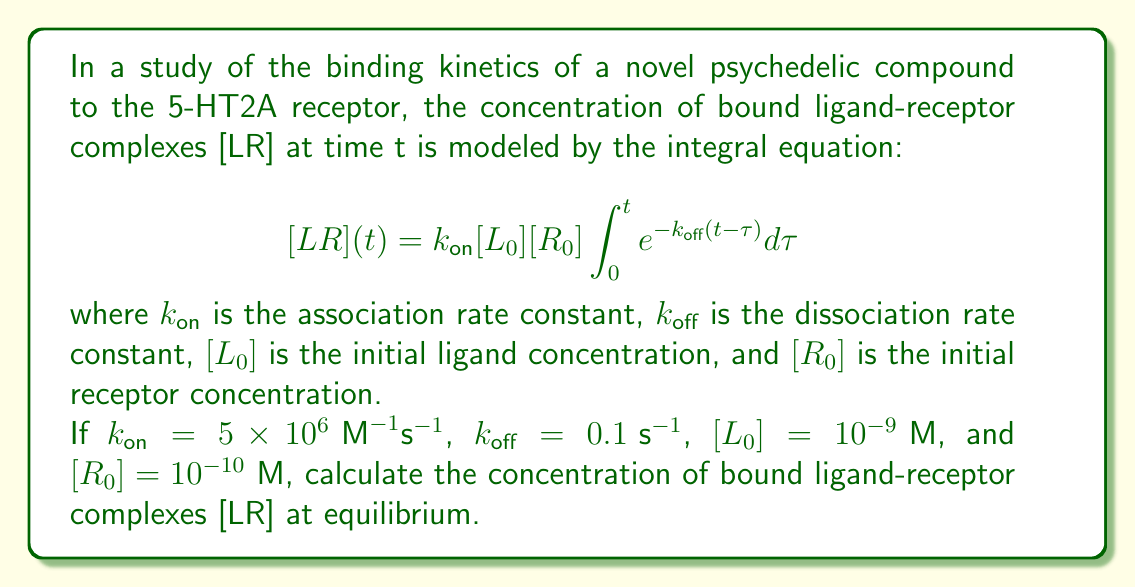Give your solution to this math problem. To solve this problem, we'll follow these steps:

1) First, we need to recognize that at equilibrium, t approaches infinity. So, we need to evaluate the limit of the integral as t → ∞:

   $$[LR]_{\text{eq}} = \lim_{t \to \infty} k_{\text{on}}[L_0][R_0]\int_0^t e^{-k_{\text{off}}(t-\tau)}d\tau$$

2) Let's solve the integral:

   $$\int_0^t e^{-k_{\text{off}}(t-\tau)}d\tau = -\frac{1}{k_{\text{off}}}[e^{-k_{\text{off}}(t-\tau)}]_0^t$$
   
   $$= -\frac{1}{k_{\text{off}}}[1 - e^{-k_{\text{off}}t}]$$

3) Now, let's take the limit as t → ∞:

   $$\lim_{t \to \infty} -\frac{1}{k_{\text{off}}}[1 - e^{-k_{\text{off}}t}] = -\frac{1}{k_{\text{off}}}[1 - 0] = \frac{1}{k_{\text{off}}}$$

4) Substituting this back into our original equation:

   $$[LR]_{\text{eq}} = k_{\text{on}}[L_0][R_0] \cdot \frac{1}{k_{\text{off}}}$$

5) Now, let's substitute the given values:

   $$[LR]_{\text{eq}} = (5 \times 10^6 \text{ M}^{-1}\text{s}^{-1})(10^{-9} \text{ M})(10^{-10} \text{ M}) \cdot \frac{1}{0.1 \text{ s}^{-1}}$$

6) Simplify:

   $$[LR]_{\text{eq}} = 5 \times 10^{-13} \text{ M} = 0.5 \text{ nM}$$

Thus, the concentration of bound ligand-receptor complexes at equilibrium is 0.5 nM.
Answer: 0.5 nM 